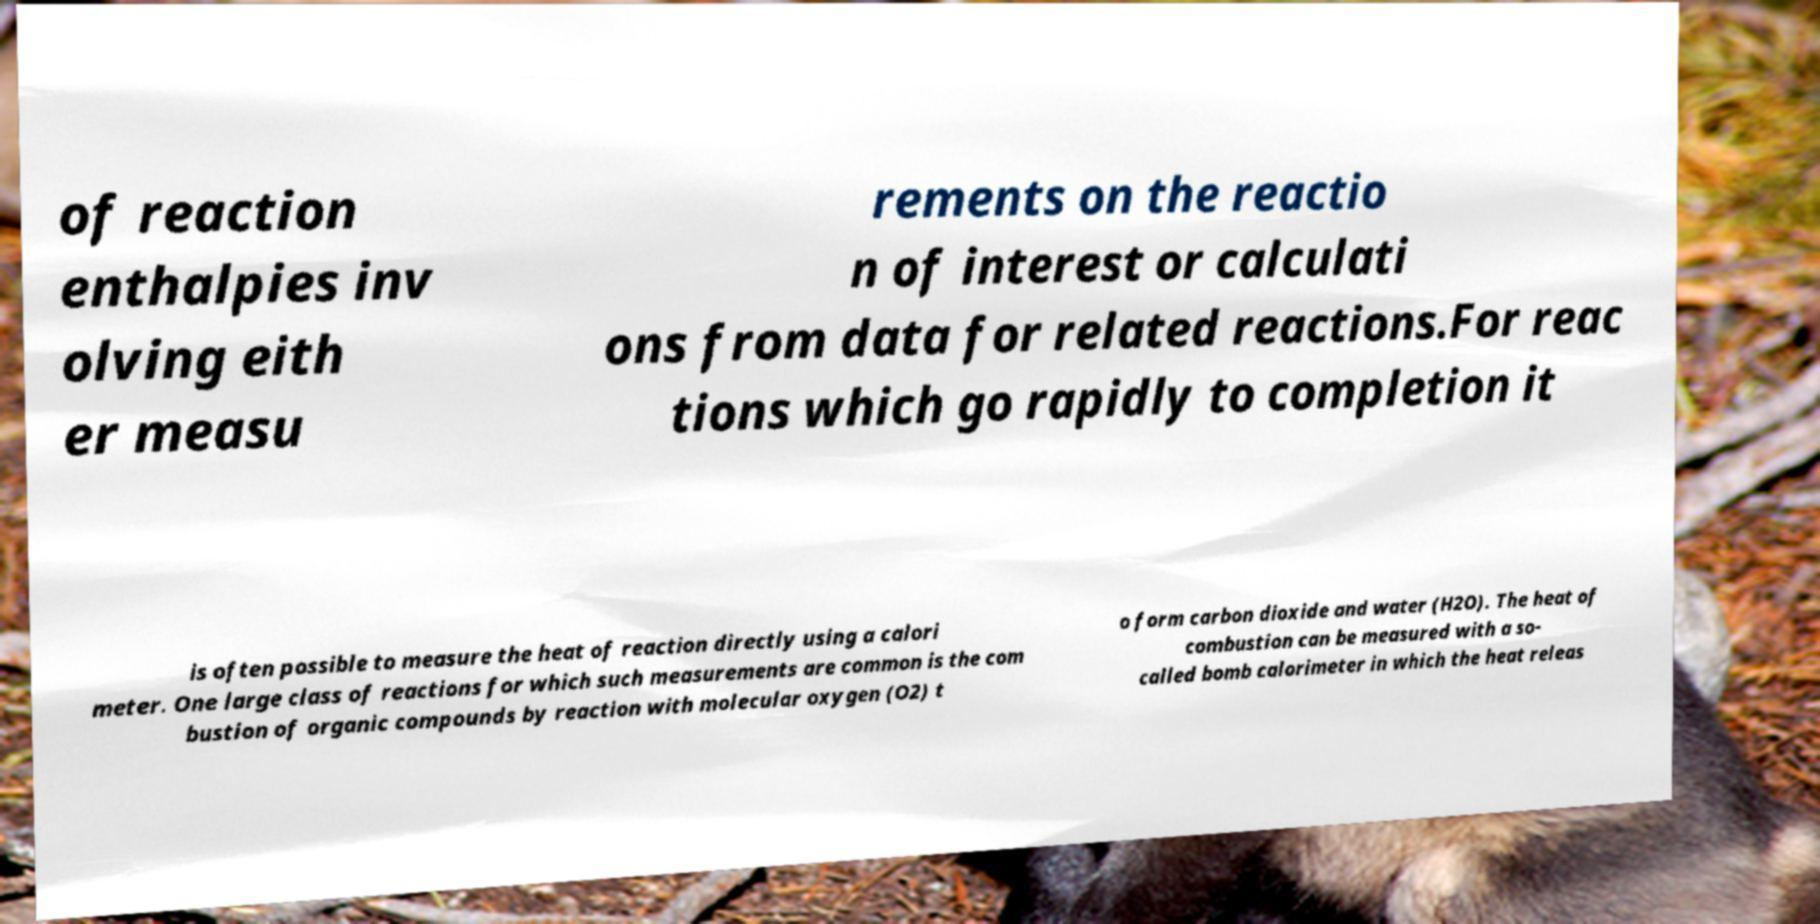Could you extract and type out the text from this image? of reaction enthalpies inv olving eith er measu rements on the reactio n of interest or calculati ons from data for related reactions.For reac tions which go rapidly to completion it is often possible to measure the heat of reaction directly using a calori meter. One large class of reactions for which such measurements are common is the com bustion of organic compounds by reaction with molecular oxygen (O2) t o form carbon dioxide and water (H2O). The heat of combustion can be measured with a so- called bomb calorimeter in which the heat releas 